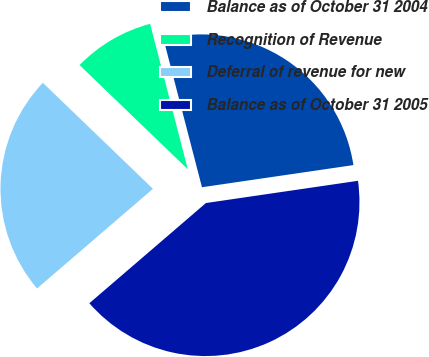Convert chart to OTSL. <chart><loc_0><loc_0><loc_500><loc_500><pie_chart><fcel>Balance as of October 31 2004<fcel>Recognition of Revenue<fcel>Deferral of revenue for new<fcel>Balance as of October 31 2005<nl><fcel>26.73%<fcel>8.76%<fcel>23.5%<fcel>41.01%<nl></chart> 